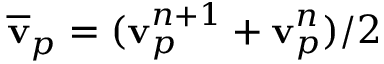Convert formula to latex. <formula><loc_0><loc_0><loc_500><loc_500>\overline { v } _ { p } = ( v _ { p } ^ { n + 1 } + v _ { p } ^ { n } ) / 2</formula> 